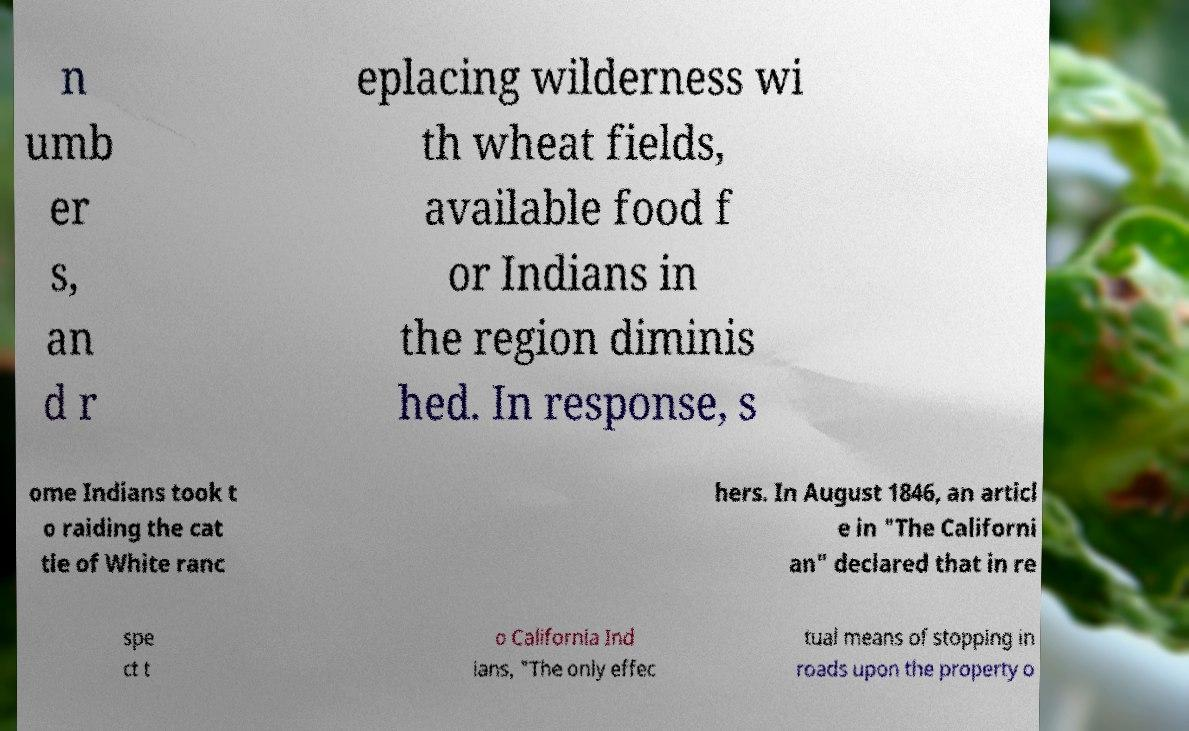For documentation purposes, I need the text within this image transcribed. Could you provide that? n umb er s, an d r eplacing wilderness wi th wheat fields, available food f or Indians in the region diminis hed. In response, s ome Indians took t o raiding the cat tle of White ranc hers. In August 1846, an articl e in "The Californi an" declared that in re spe ct t o California Ind ians, "The only effec tual means of stopping in roads upon the property o 